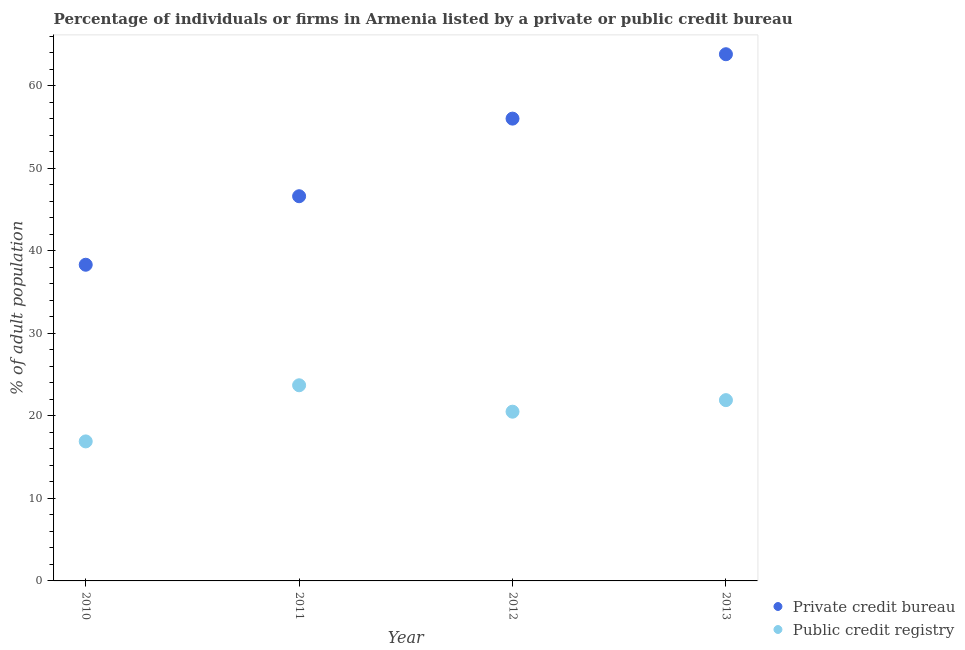How many different coloured dotlines are there?
Offer a terse response. 2. Is the number of dotlines equal to the number of legend labels?
Keep it short and to the point. Yes. What is the percentage of firms listed by private credit bureau in 2012?
Make the answer very short. 56. Across all years, what is the maximum percentage of firms listed by public credit bureau?
Your answer should be compact. 23.7. Across all years, what is the minimum percentage of firms listed by public credit bureau?
Your answer should be very brief. 16.9. In which year was the percentage of firms listed by private credit bureau minimum?
Keep it short and to the point. 2010. What is the total percentage of firms listed by private credit bureau in the graph?
Offer a terse response. 204.7. What is the difference between the percentage of firms listed by public credit bureau in 2010 and that in 2012?
Keep it short and to the point. -3.6. What is the difference between the percentage of firms listed by public credit bureau in 2012 and the percentage of firms listed by private credit bureau in 2013?
Offer a very short reply. -43.3. What is the average percentage of firms listed by public credit bureau per year?
Offer a terse response. 20.75. In the year 2013, what is the difference between the percentage of firms listed by public credit bureau and percentage of firms listed by private credit bureau?
Your answer should be compact. -41.9. In how many years, is the percentage of firms listed by private credit bureau greater than 52 %?
Your answer should be very brief. 2. What is the ratio of the percentage of firms listed by public credit bureau in 2010 to that in 2013?
Offer a very short reply. 0.77. Is the difference between the percentage of firms listed by private credit bureau in 2010 and 2013 greater than the difference between the percentage of firms listed by public credit bureau in 2010 and 2013?
Give a very brief answer. No. What is the difference between the highest and the second highest percentage of firms listed by private credit bureau?
Provide a short and direct response. 7.8. What is the difference between the highest and the lowest percentage of firms listed by private credit bureau?
Your answer should be very brief. 25.5. Is the percentage of firms listed by private credit bureau strictly greater than the percentage of firms listed by public credit bureau over the years?
Offer a terse response. Yes. How many dotlines are there?
Your response must be concise. 2. How many years are there in the graph?
Ensure brevity in your answer.  4. What is the difference between two consecutive major ticks on the Y-axis?
Provide a short and direct response. 10. Does the graph contain grids?
Make the answer very short. No. Where does the legend appear in the graph?
Your answer should be very brief. Bottom right. How are the legend labels stacked?
Your answer should be compact. Vertical. What is the title of the graph?
Offer a terse response. Percentage of individuals or firms in Armenia listed by a private or public credit bureau. What is the label or title of the X-axis?
Your answer should be compact. Year. What is the label or title of the Y-axis?
Make the answer very short. % of adult population. What is the % of adult population in Private credit bureau in 2010?
Make the answer very short. 38.3. What is the % of adult population in Public credit registry in 2010?
Make the answer very short. 16.9. What is the % of adult population of Private credit bureau in 2011?
Provide a short and direct response. 46.6. What is the % of adult population in Public credit registry in 2011?
Make the answer very short. 23.7. What is the % of adult population in Private credit bureau in 2012?
Make the answer very short. 56. What is the % of adult population in Public credit registry in 2012?
Your response must be concise. 20.5. What is the % of adult population of Private credit bureau in 2013?
Provide a short and direct response. 63.8. What is the % of adult population in Public credit registry in 2013?
Your answer should be very brief. 21.9. Across all years, what is the maximum % of adult population of Private credit bureau?
Make the answer very short. 63.8. Across all years, what is the maximum % of adult population of Public credit registry?
Give a very brief answer. 23.7. Across all years, what is the minimum % of adult population in Private credit bureau?
Make the answer very short. 38.3. What is the total % of adult population of Private credit bureau in the graph?
Offer a very short reply. 204.7. What is the total % of adult population of Public credit registry in the graph?
Offer a terse response. 83. What is the difference between the % of adult population in Private credit bureau in 2010 and that in 2011?
Offer a terse response. -8.3. What is the difference between the % of adult population in Private credit bureau in 2010 and that in 2012?
Your answer should be very brief. -17.7. What is the difference between the % of adult population of Public credit registry in 2010 and that in 2012?
Keep it short and to the point. -3.6. What is the difference between the % of adult population of Private credit bureau in 2010 and that in 2013?
Offer a very short reply. -25.5. What is the difference between the % of adult population of Private credit bureau in 2011 and that in 2012?
Your answer should be compact. -9.4. What is the difference between the % of adult population in Public credit registry in 2011 and that in 2012?
Offer a very short reply. 3.2. What is the difference between the % of adult population in Private credit bureau in 2011 and that in 2013?
Provide a short and direct response. -17.2. What is the difference between the % of adult population of Public credit registry in 2012 and that in 2013?
Your response must be concise. -1.4. What is the difference between the % of adult population of Private credit bureau in 2010 and the % of adult population of Public credit registry in 2011?
Offer a very short reply. 14.6. What is the difference between the % of adult population of Private credit bureau in 2010 and the % of adult population of Public credit registry in 2012?
Offer a very short reply. 17.8. What is the difference between the % of adult population of Private credit bureau in 2011 and the % of adult population of Public credit registry in 2012?
Give a very brief answer. 26.1. What is the difference between the % of adult population in Private credit bureau in 2011 and the % of adult population in Public credit registry in 2013?
Your response must be concise. 24.7. What is the difference between the % of adult population of Private credit bureau in 2012 and the % of adult population of Public credit registry in 2013?
Make the answer very short. 34.1. What is the average % of adult population in Private credit bureau per year?
Provide a succinct answer. 51.17. What is the average % of adult population of Public credit registry per year?
Provide a short and direct response. 20.75. In the year 2010, what is the difference between the % of adult population of Private credit bureau and % of adult population of Public credit registry?
Ensure brevity in your answer.  21.4. In the year 2011, what is the difference between the % of adult population of Private credit bureau and % of adult population of Public credit registry?
Offer a very short reply. 22.9. In the year 2012, what is the difference between the % of adult population in Private credit bureau and % of adult population in Public credit registry?
Give a very brief answer. 35.5. In the year 2013, what is the difference between the % of adult population of Private credit bureau and % of adult population of Public credit registry?
Your answer should be very brief. 41.9. What is the ratio of the % of adult population of Private credit bureau in 2010 to that in 2011?
Your answer should be compact. 0.82. What is the ratio of the % of adult population of Public credit registry in 2010 to that in 2011?
Your answer should be very brief. 0.71. What is the ratio of the % of adult population in Private credit bureau in 2010 to that in 2012?
Your answer should be very brief. 0.68. What is the ratio of the % of adult population in Public credit registry in 2010 to that in 2012?
Ensure brevity in your answer.  0.82. What is the ratio of the % of adult population in Private credit bureau in 2010 to that in 2013?
Make the answer very short. 0.6. What is the ratio of the % of adult population in Public credit registry in 2010 to that in 2013?
Provide a succinct answer. 0.77. What is the ratio of the % of adult population in Private credit bureau in 2011 to that in 2012?
Make the answer very short. 0.83. What is the ratio of the % of adult population of Public credit registry in 2011 to that in 2012?
Ensure brevity in your answer.  1.16. What is the ratio of the % of adult population in Private credit bureau in 2011 to that in 2013?
Keep it short and to the point. 0.73. What is the ratio of the % of adult population in Public credit registry in 2011 to that in 2013?
Provide a succinct answer. 1.08. What is the ratio of the % of adult population of Private credit bureau in 2012 to that in 2013?
Offer a very short reply. 0.88. What is the ratio of the % of adult population of Public credit registry in 2012 to that in 2013?
Your answer should be compact. 0.94. What is the difference between the highest and the lowest % of adult population of Private credit bureau?
Keep it short and to the point. 25.5. What is the difference between the highest and the lowest % of adult population in Public credit registry?
Provide a succinct answer. 6.8. 